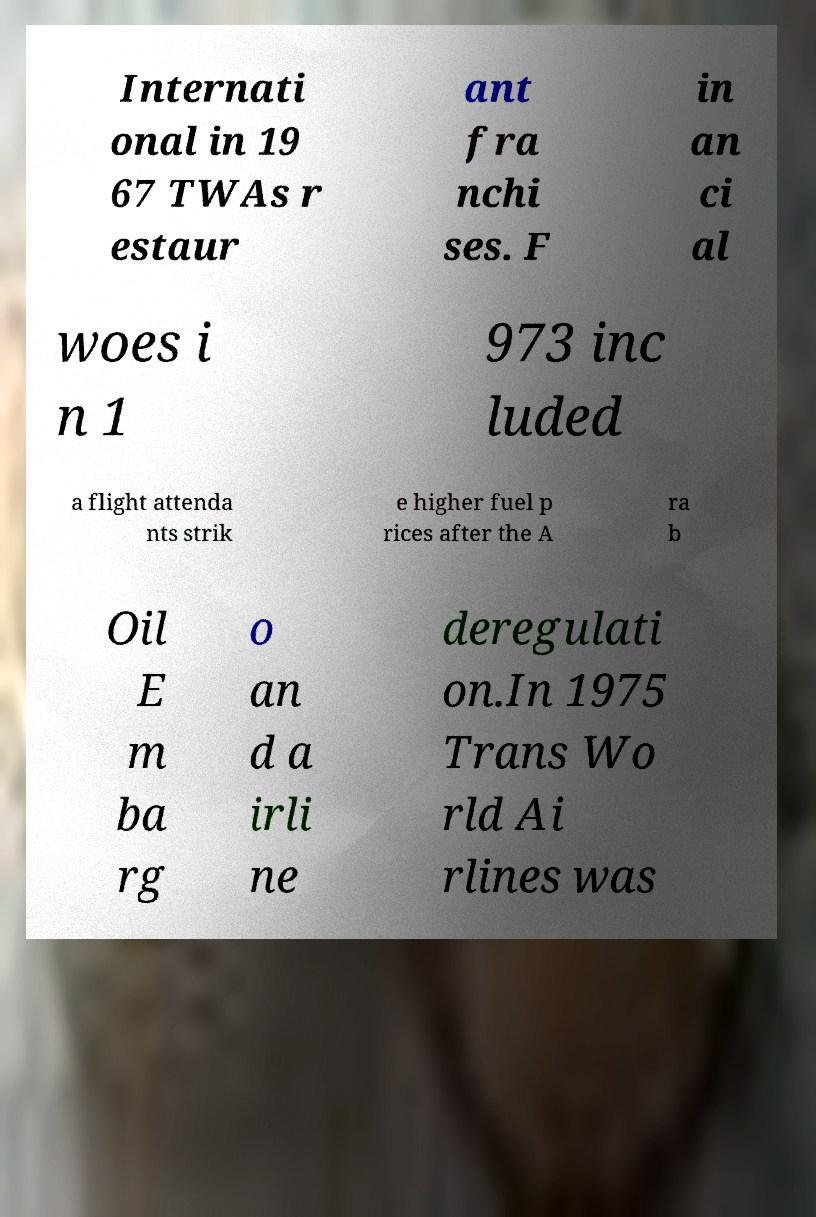There's text embedded in this image that I need extracted. Can you transcribe it verbatim? Internati onal in 19 67 TWAs r estaur ant fra nchi ses. F in an ci al woes i n 1 973 inc luded a flight attenda nts strik e higher fuel p rices after the A ra b Oil E m ba rg o an d a irli ne deregulati on.In 1975 Trans Wo rld Ai rlines was 